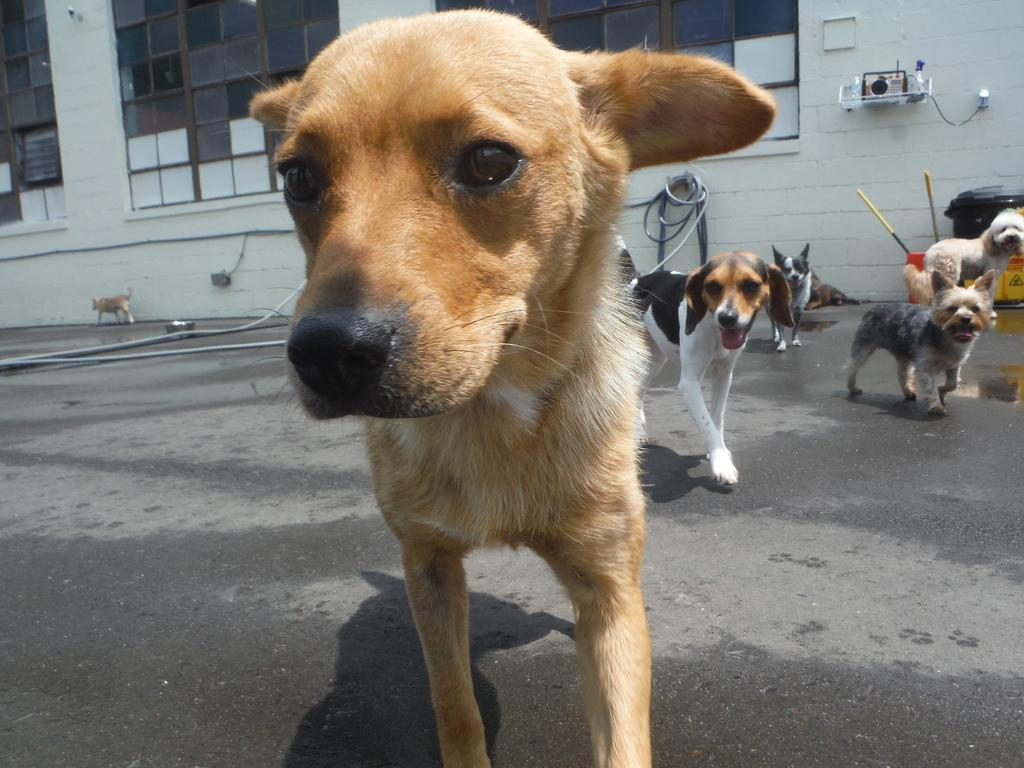What animals are on the ground in the image? There are dogs on the ground in the image. What can be seen in the background of the image? There is a building in the background of the image. How many spiders are crawling on the dogs in the image? There are no spiders present in the image; it features dogs on the ground and a building in the background. 